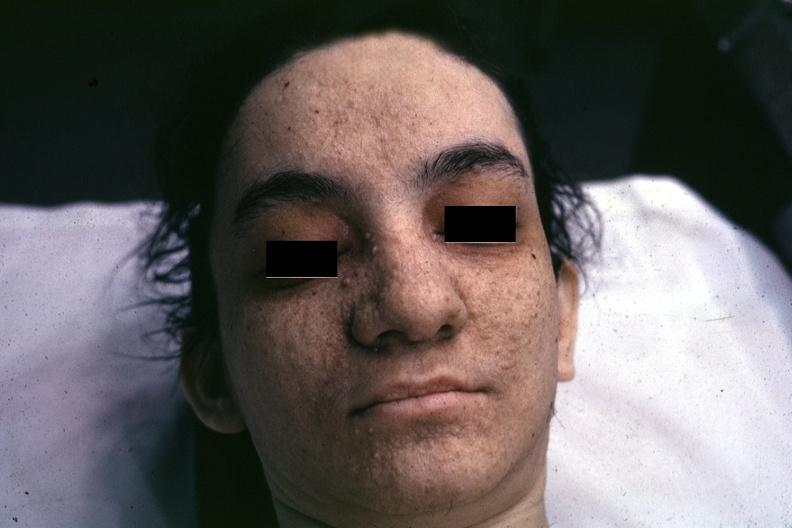does hypertension show very good example associated with tuberous sclerosis?
Answer the question using a single word or phrase. No 